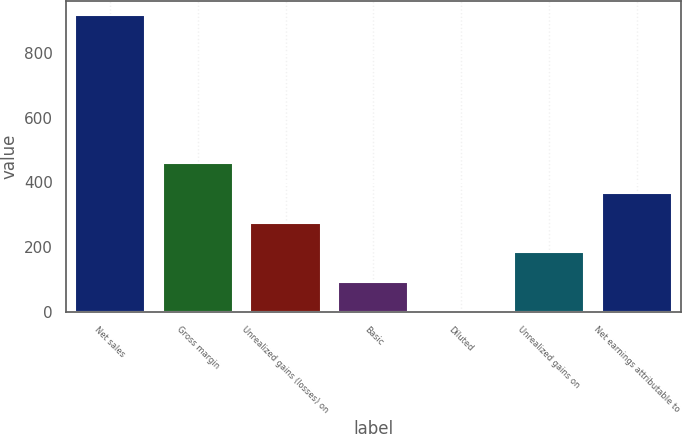Convert chart to OTSL. <chart><loc_0><loc_0><loc_500><loc_500><bar_chart><fcel>Net sales<fcel>Gross margin<fcel>Unrealized gains (losses) on<fcel>Basic<fcel>Diluted<fcel>Unrealized gains on<fcel>Net earnings attributable to<nl><fcel>917.1<fcel>458.87<fcel>275.59<fcel>92.31<fcel>0.67<fcel>183.95<fcel>367.23<nl></chart> 